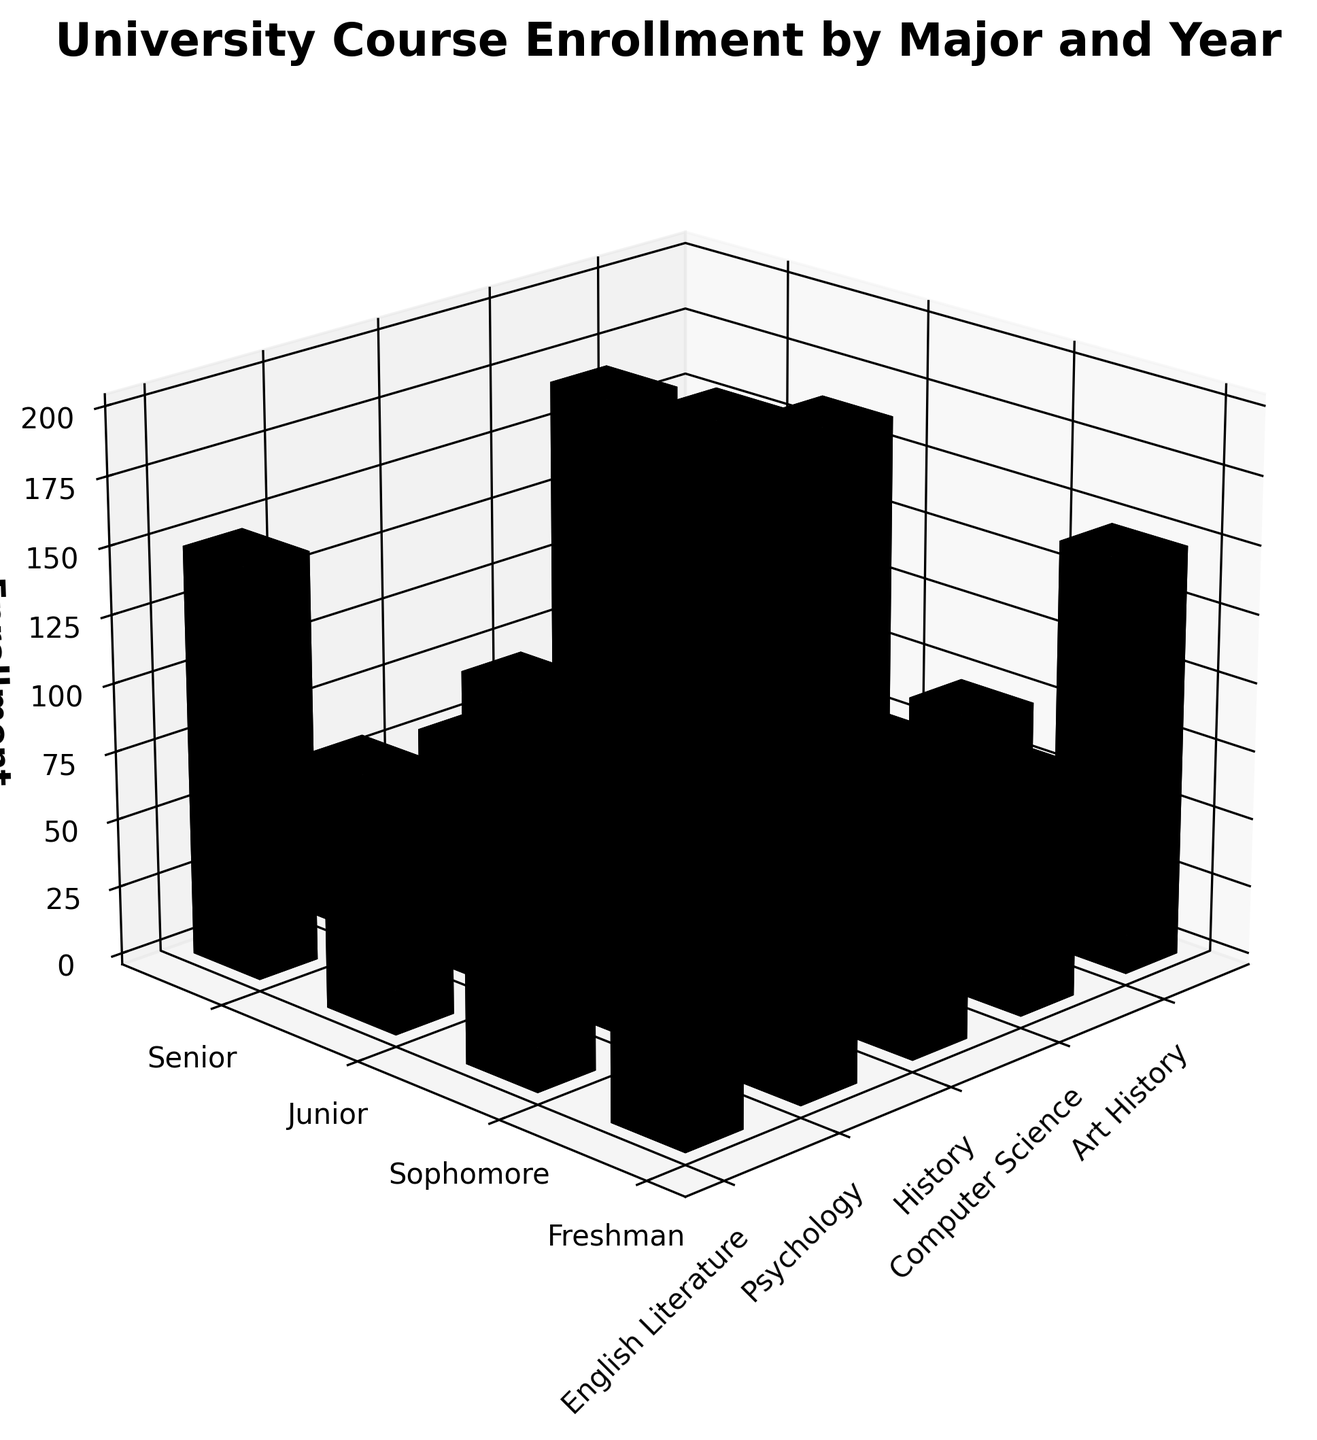What's the title of the figure? The title is usually displayed at the top of the figure. In this case, it should be visible near the top center due to the default plotting settings.
Answer: University Course Enrollment by Major and Year How many majors are represented in the figure? Majors are usually labeled on one of the axes, most likely the x-axis in this 3D plot. By counting the labels along this axis, we identify the number of unique majors.
Answer: 5 Which major has the highest enrollment for Freshmen? Locate the bars corresponding to Freshman year on the y-axis, then identify which has the highest bar among these for the majors labeled on the x-axis.
Answer: Computer Science What's the total enrollment for Junior year across all majors? Add the heights of all the bars corresponding to the Junior year. The relevant data points are: 95 (English Literature) + 130 (Psychology) + 70 (History) + 165 (Computer Science) + 50 (Art History). Sum these values to get the total.
Answer: 510 Which year level has the lowest enrollment in Art History? Find the columns labeled "Art History" on the x-axis, then compare the heights of bars corresponding to different year levels on the y-axis to find the shortest one.
Answer: Senior Is the enrollment for Senior year higher in Psychology or History? Compare the bar heights of Senior year (y-axis) for both majors. The height for Psychology is 115, and for History, it is 65.
Answer: Psychology What's the average enrollment for all year levels across all majors? Compute the average by summing all the enrollments and dividing by the number of data points. The total enrollment values are: 120+105+95+85+150+140+130+115+80+75+70+65+200+180+165+150+60+55+50+45 = 2130. There are 20 data points, so the average is 2130/20.
Answer: 106.5 Which major shows a decrease in enrollment from Freshman to Senior year? Compare the heights of the bars for each major from Freshman to Senior year. All majors have lower enrollment in Senior year compared to Freshman year, so identify any that demonstrate this trend.
Answer: All majors What is the difference in enrollment between Sophomore and Junior years for Computer Science? Identify the heights of the bars for Computer Science in the Sophomore and Junior year levels. Sophomore: 180, Junior: 165. Calculate the difference (180 - 165).
Answer: 15 Do Freshmen enrollments exceed Senior enrollments on average? Calculate the average for Freshman enrollments and Senior enrollments separately. Freshman: (120+150+80+200+60)/5 = 122, Senior: (85+115+65+150+45)/5 = 92. Compare the two averages.
Answer: Yes 